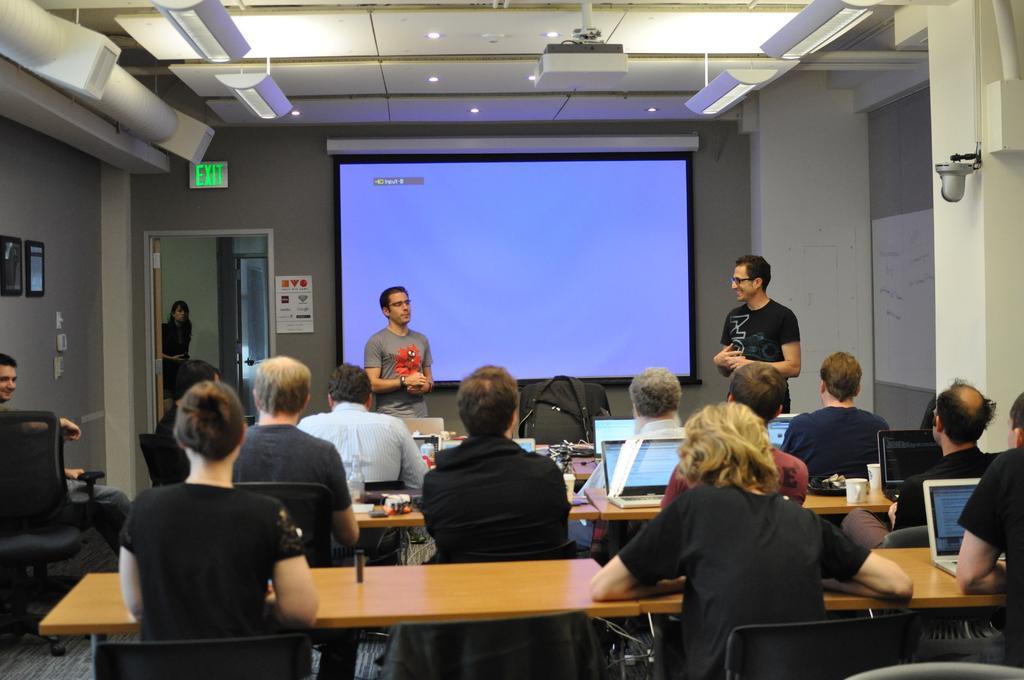Can you describe this image briefly? In this image there are group of persons sitting on the chairs at the background of the image there are two persons standing and there is a projector screen,projector and at the left side of the image there is a woman standing outside the door. 